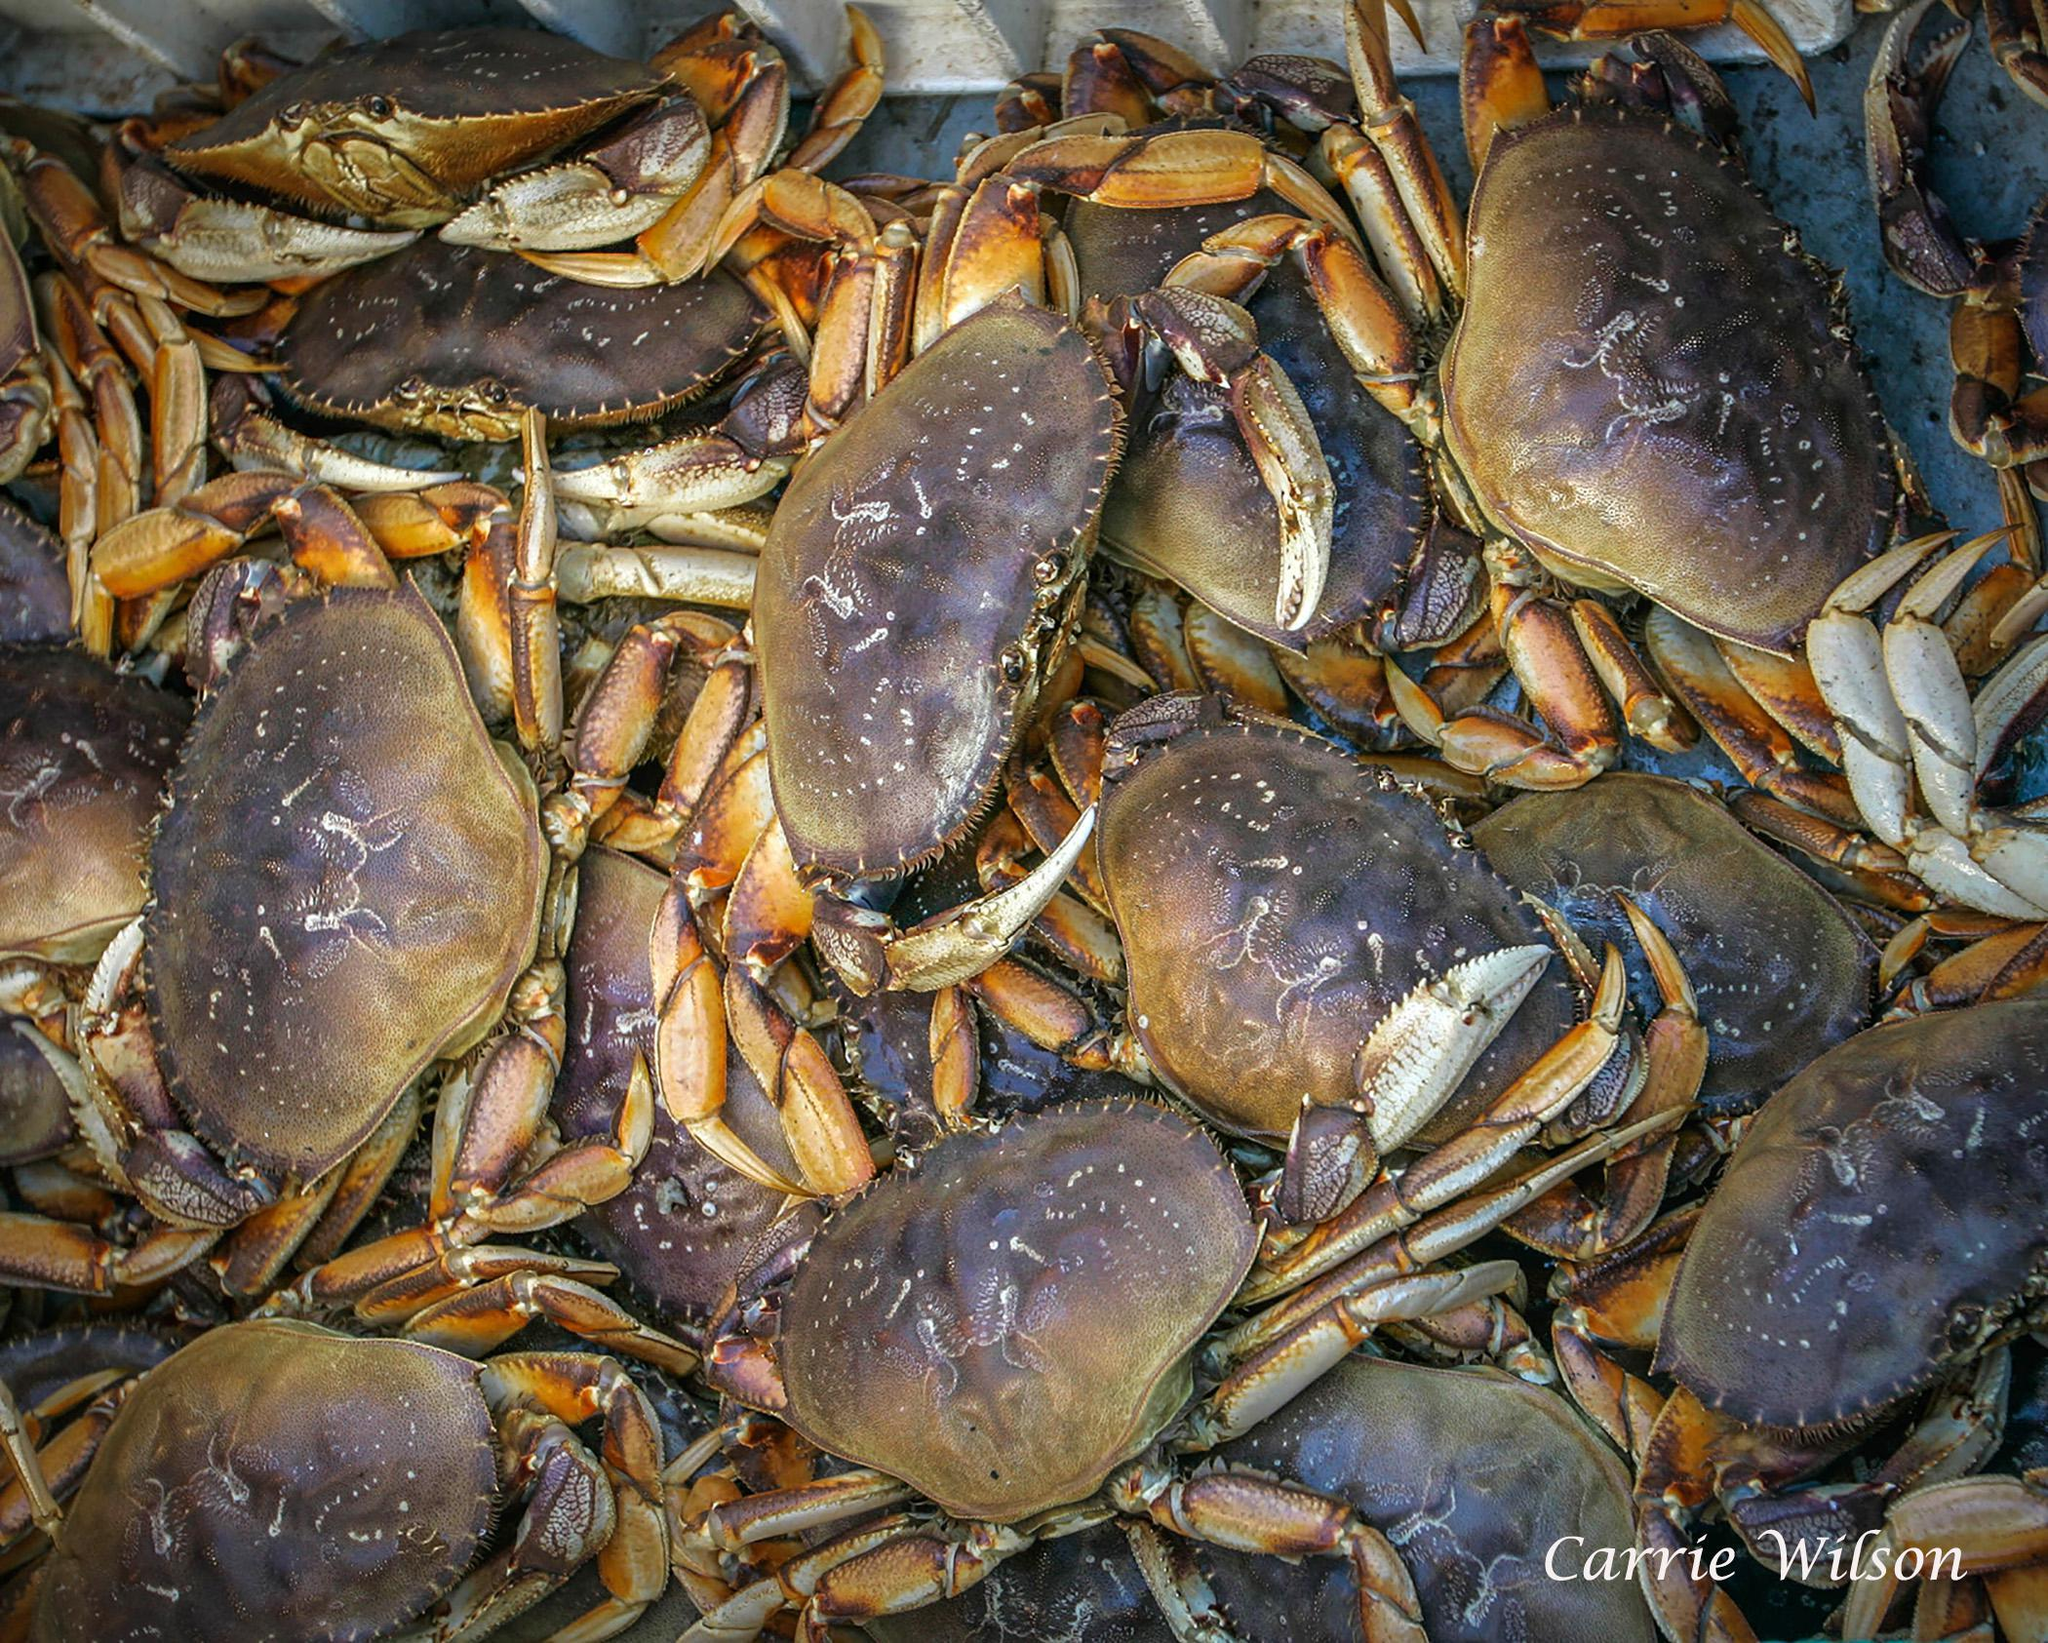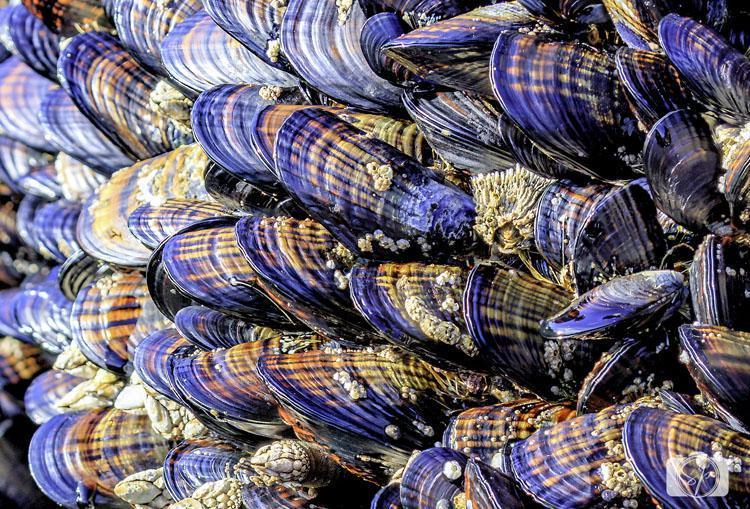The first image is the image on the left, the second image is the image on the right. For the images shown, is this caption "There are crabs in cages." true? Answer yes or no. No. The first image is the image on the left, the second image is the image on the right. For the images displayed, is the sentence "At least one image shows crabs in a container with a grid of squares and a metal frame." factually correct? Answer yes or no. No. 